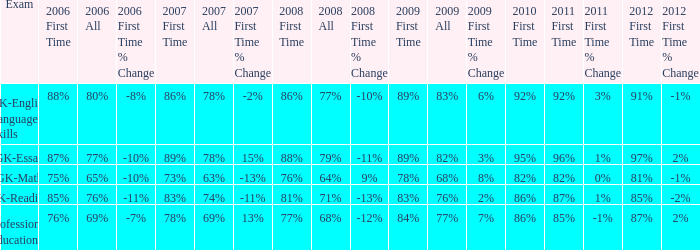Would you mind parsing the complete table? {'header': ['Exam', '2006 First Time', '2006 All', '2006 First Time % Change', '2007 First Time', '2007 All', '2007 First Time % Change', '2008 First Time', '2008 All', '2008 First Time % Change', '2009 First Time', '2009 All', '2009 First Time % Change', '2010 First Time', '2011 First Time', '2011 First Time % Change', '2012 First Time', '2012 First Time % Change'], 'rows': [['GK-English Language Skills', '88%', '80%', '-8%', '86%', '78%', '-2%', '86%', '77%', '-10%', '89%', '83%', '6%', '92%', '92%', '3%', '91%', '-1%'], ['GK-Essay', '87%', '77%', '-10%', '89%', '78%', '15%', '88%', '79%', '-11%', '89%', '82%', '3%', '95%', '96%', '1%', '97%', '2%'], ['GK-Math', '75%', '65%', '-10%', '73%', '63%', '-13%', '76%', '64%', '9%', '78%', '68%', '8%', '82%', '82%', '0%', '81%', '-1%'], ['GK-Reading', '85%', '76%', '-11%', '83%', '74%', '-11%', '81%', '71%', '-13%', '83%', '76%', '2%', '86%', '87%', '1%', '85%', '-2%'], ['Professional Education', '76%', '69%', '-7%', '78%', '69%', '13%', '77%', '68%', '-12%', '84%', '77%', '7%', '86%', '85%', '-1%', '87%', '2%']]} What is the percentage for first time in 2012 when it was 82% for all in 2009? 97%. 